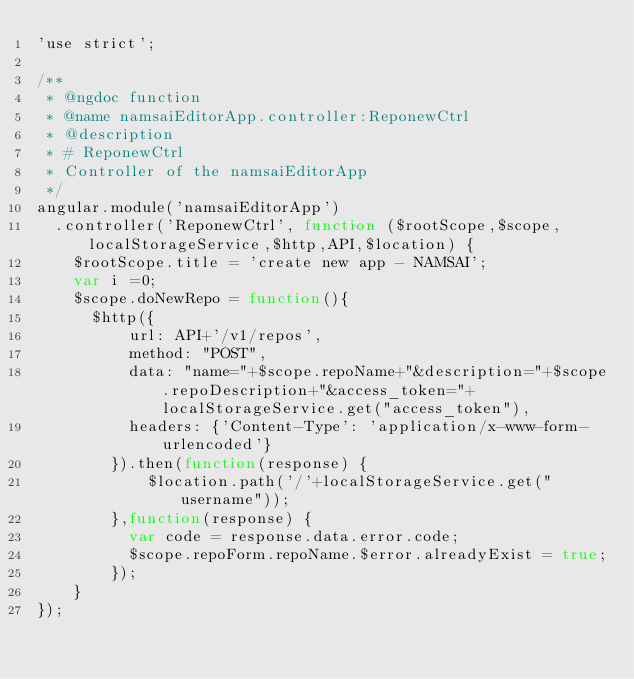<code> <loc_0><loc_0><loc_500><loc_500><_JavaScript_>'use strict';

/**
 * @ngdoc function
 * @name namsaiEditorApp.controller:ReponewCtrl
 * @description
 * # ReponewCtrl
 * Controller of the namsaiEditorApp
 */
angular.module('namsaiEditorApp')
  .controller('ReponewCtrl', function ($rootScope,$scope,localStorageService,$http,API,$location) {
    $rootScope.title = 'create new app - NAMSAI';
    var i =0;
    $scope.doNewRepo = function(){
      $http({
          url: API+'/v1/repos',
          method: "POST",
          data: "name="+$scope.repoName+"&description="+$scope.repoDescription+"&access_token="+localStorageService.get("access_token"),
          headers: {'Content-Type': 'application/x-www-form-urlencoded'}
        }).then(function(response) {
            $location.path('/'+localStorageService.get("username"));
        },function(response) {
          var code = response.data.error.code;
          $scope.repoForm.repoName.$error.alreadyExist = true;
        });
    }
});
</code> 